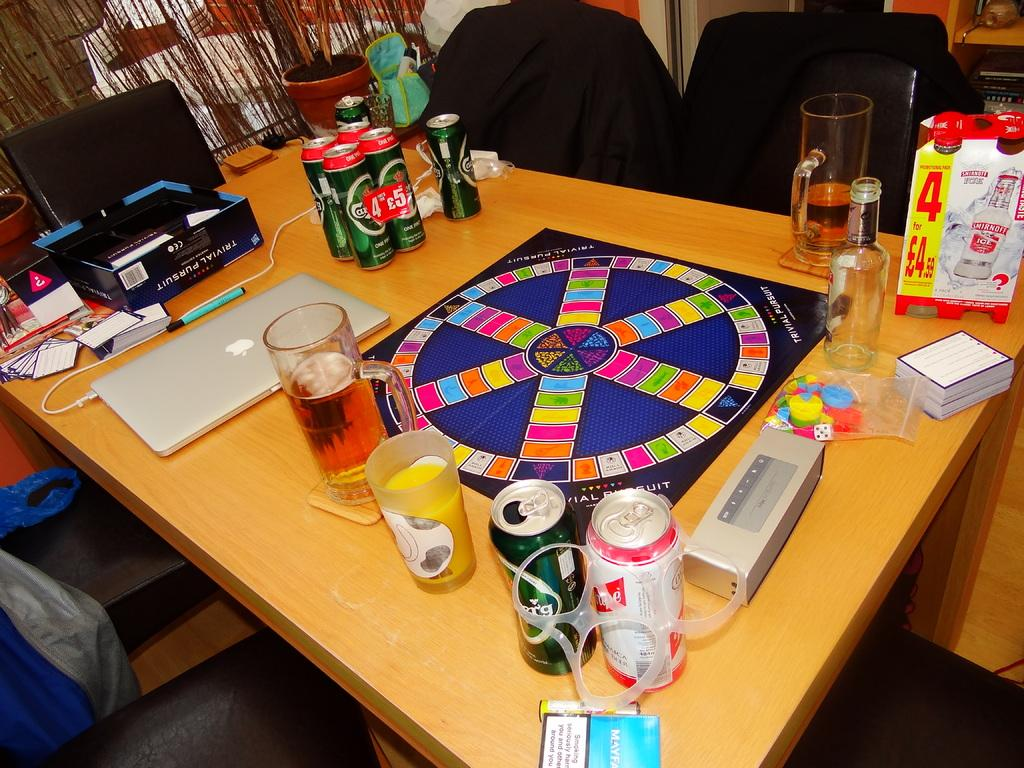What objects are on the table in the image? There are glasses, tins, a box, and a laptop on the table in the image. What type of furniture is located beside the table? There are chairs beside the table. What is the additional object beside the table? There is a flower pot beside the table. What type of yak can be seen in the image? There is no yak present in the image. What type of advertisement can be seen on the laptop screen in the image? There is no advertisement visible on the laptop screen in the image. 